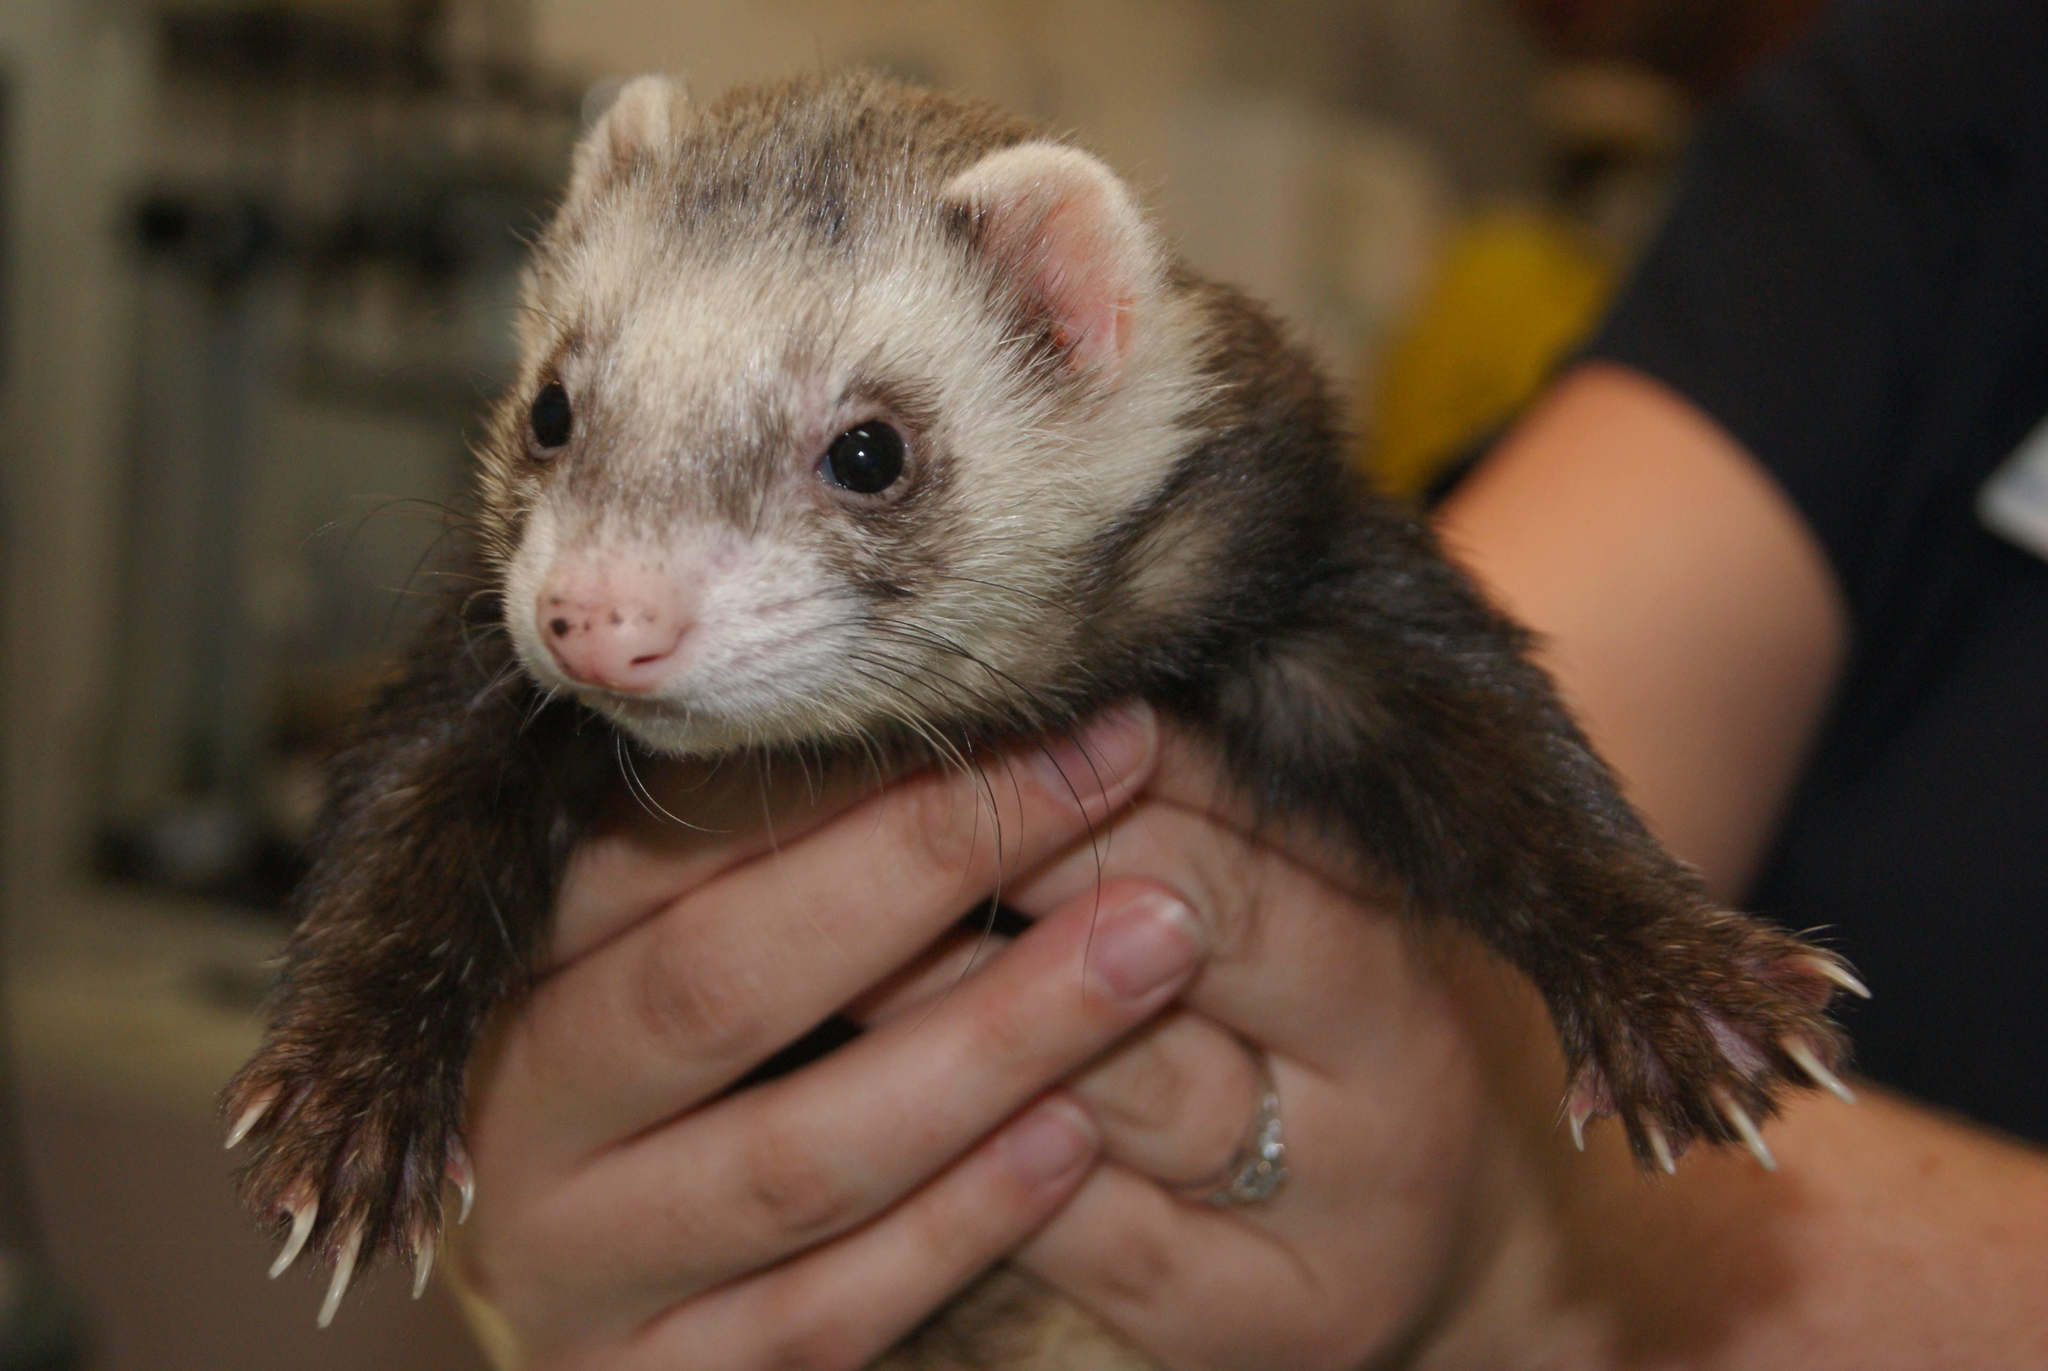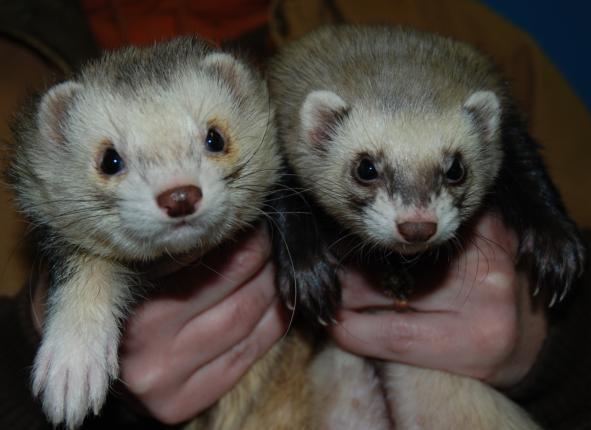The first image is the image on the left, the second image is the image on the right. Analyze the images presented: Is the assertion "The right image contains exactly one ferret." valid? Answer yes or no. No. The first image is the image on the left, the second image is the image on the right. For the images displayed, is the sentence "The right image contains twice as many ferrets as the left image." factually correct? Answer yes or no. Yes. 